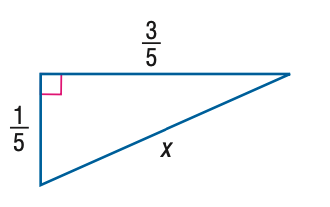Question: Find x.
Choices:
A. \frac { \sqrt { 5 } } { 10 }
B. \frac { \sqrt { 10 } } { 10 }
C. \frac { \sqrt { 5 } } { 5 }
D. \frac { \sqrt { 10 } } { 5 }
Answer with the letter. Answer: D 